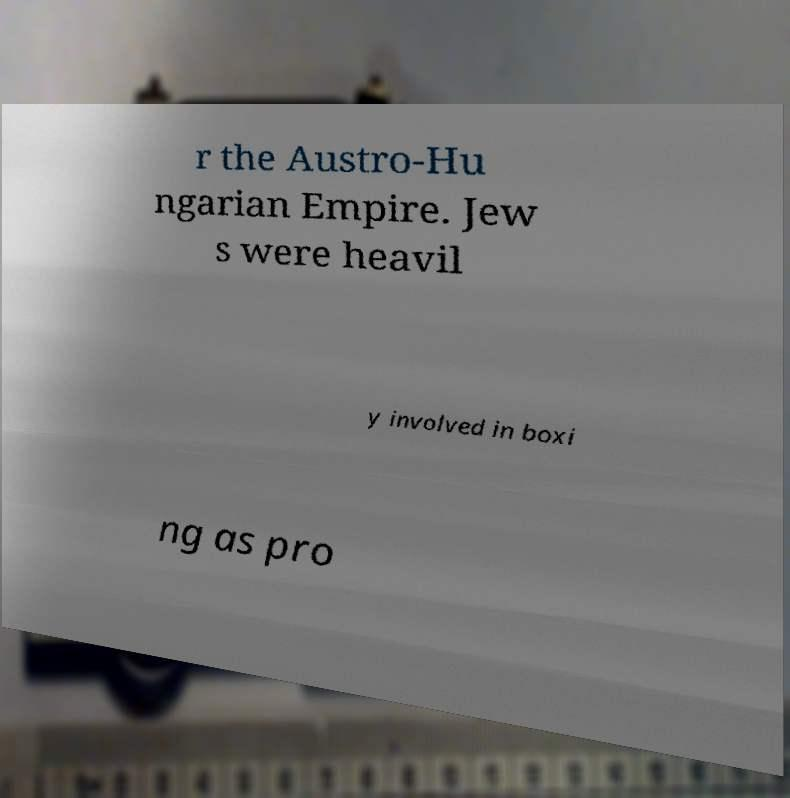What messages or text are displayed in this image? I need them in a readable, typed format. r the Austro-Hu ngarian Empire. Jew s were heavil y involved in boxi ng as pro 